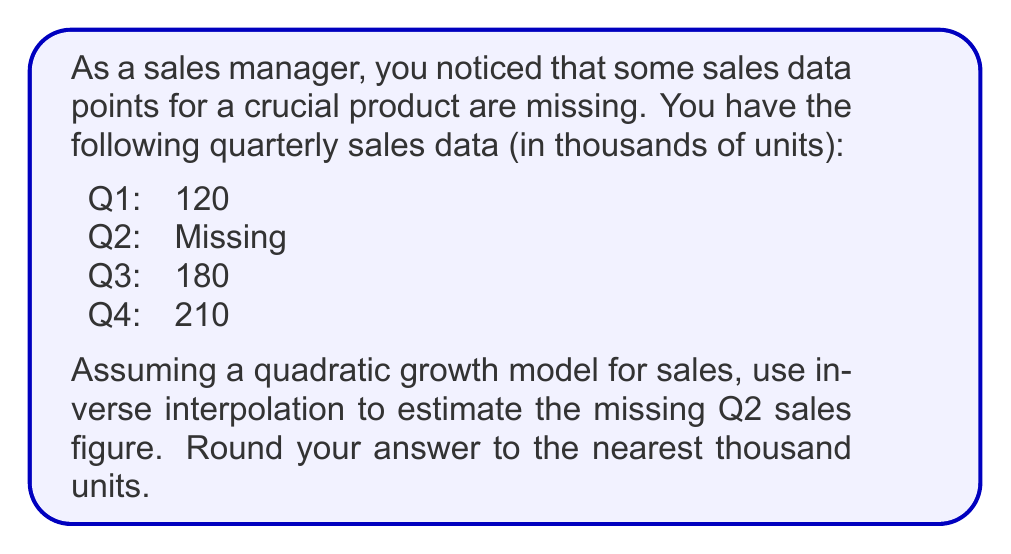Give your solution to this math problem. To solve this problem, we'll use quadratic interpolation and the inverse problem technique:

1. Let's assume the quadratic model: $f(t) = at^2 + bt + c$, where $t$ is the quarter number (1, 2, 3, 4) and $f(t)$ is the sales in thousands of units.

2. We have three known data points:
   $f(1) = 120$
   $f(3) = 180$
   $f(4) = 210$

3. Substitute these into the quadratic equation:
   $120 = a(1)^2 + b(1) + c$
   $180 = a(3)^2 + b(3) + c$
   $210 = a(4)^2 + b(4) + c$

4. Simplify:
   $120 = a + b + c$
   $180 = 9a + 3b + c$
   $210 = 16a + 4b + c$

5. Subtract the first equation from the second and third:
   $60 = 8a + 2b$
   $90 = 15a + 3b$

6. Multiply the first equation by 3 and the second by 2:
   $180 = 24a + 6b$
   $180 = 30a + 6b$

7. Subtract these equations:
   $0 = -6a$
   $a = 0$

8. Substitute $a = 0$ into $60 = 8a + 2b$:
   $60 = 2b$
   $b = 30$

9. Substitute $a = 0$ and $b = 30$ into $120 = a + b + c$:
   $120 = 0 + 30 + c$
   $c = 90$

10. Our quadratic model is now: $f(t) = 30t + 90$

11. To find Q2 sales, calculate $f(2)$:
    $f(2) = 30(2) + 90 = 150$

Therefore, the estimated Q2 sales figure is 150 thousand units.
Answer: 150,000 units 